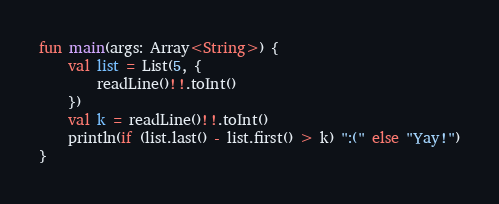<code> <loc_0><loc_0><loc_500><loc_500><_Kotlin_>fun main(args: Array<String>) {
    val list = List(5, {
        readLine()!!.toInt()
    })
    val k = readLine()!!.toInt()
    println(if (list.last() - list.first() > k) ":(" else "Yay!")
}</code> 